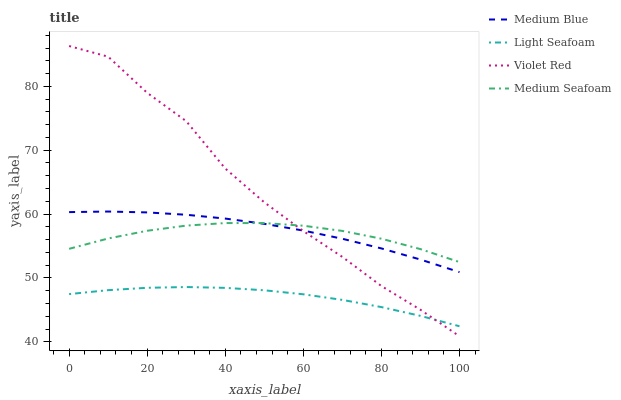Does Light Seafoam have the minimum area under the curve?
Answer yes or no. Yes. Does Violet Red have the maximum area under the curve?
Answer yes or no. Yes. Does Medium Blue have the minimum area under the curve?
Answer yes or no. No. Does Medium Blue have the maximum area under the curve?
Answer yes or no. No. Is Medium Blue the smoothest?
Answer yes or no. Yes. Is Violet Red the roughest?
Answer yes or no. Yes. Is Light Seafoam the smoothest?
Answer yes or no. No. Is Light Seafoam the roughest?
Answer yes or no. No. Does Violet Red have the lowest value?
Answer yes or no. Yes. Does Light Seafoam have the lowest value?
Answer yes or no. No. Does Violet Red have the highest value?
Answer yes or no. Yes. Does Medium Blue have the highest value?
Answer yes or no. No. Is Light Seafoam less than Medium Seafoam?
Answer yes or no. Yes. Is Medium Seafoam greater than Light Seafoam?
Answer yes or no. Yes. Does Medium Seafoam intersect Medium Blue?
Answer yes or no. Yes. Is Medium Seafoam less than Medium Blue?
Answer yes or no. No. Is Medium Seafoam greater than Medium Blue?
Answer yes or no. No. Does Light Seafoam intersect Medium Seafoam?
Answer yes or no. No. 